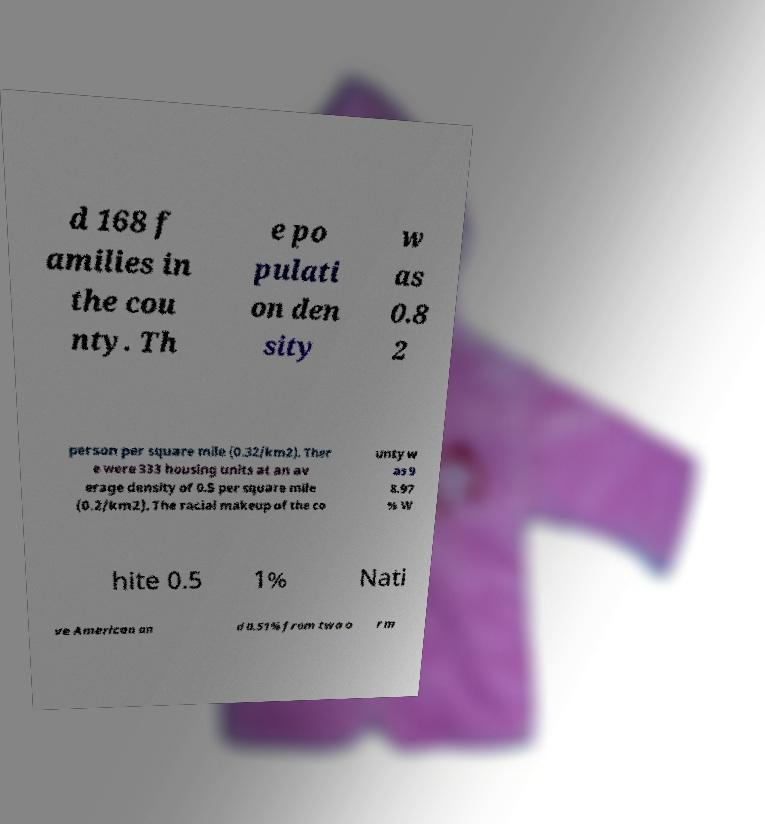What messages or text are displayed in this image? I need them in a readable, typed format. d 168 f amilies in the cou nty. Th e po pulati on den sity w as 0.8 2 person per square mile (0.32/km2). Ther e were 333 housing units at an av erage density of 0.5 per square mile (0.2/km2). The racial makeup of the co unty w as 9 8.97 % W hite 0.5 1% Nati ve American an d 0.51% from two o r m 